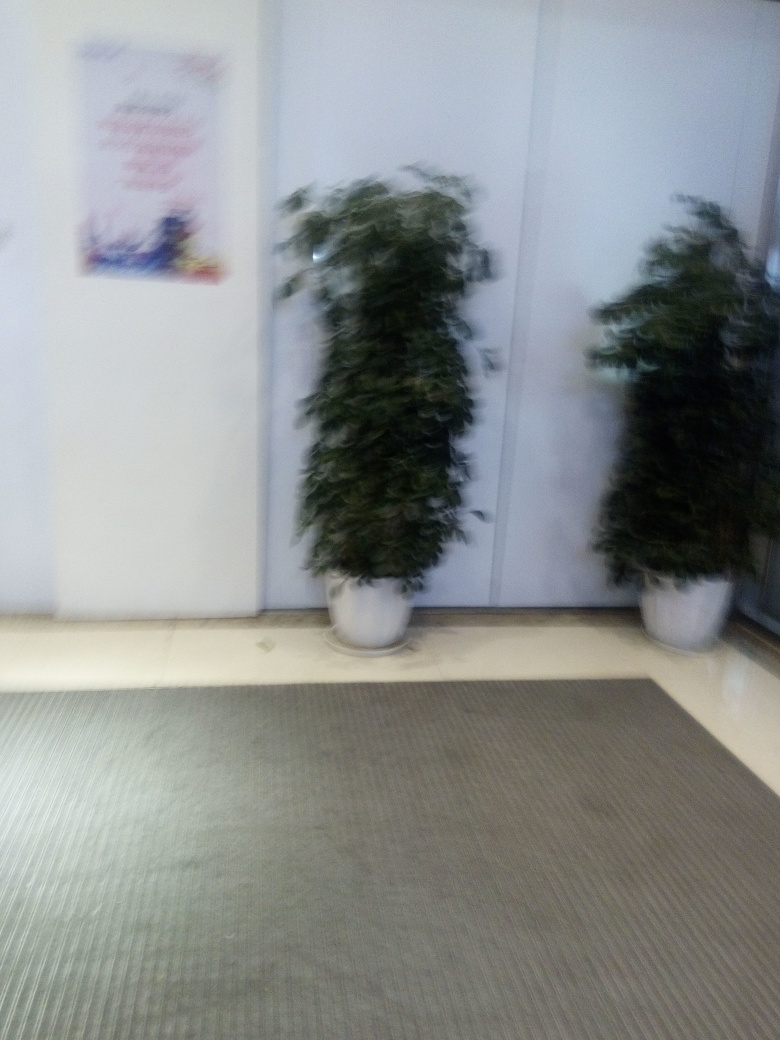Is the overall quality of this photo low? Yes, the overall quality of the photo is indeed low. This assessment is based on the noticeable blur and lack of sharpness in the image, which hinder the clear depiction of the subjects, in this case, two potted plants. Additionally, there is a lack of proper focus, and the lighting conditions do not appear to be optimal, contributing to the image's poor quality. Such characteristics are typical indicators used to evaluate the technical quality of a photograph. 